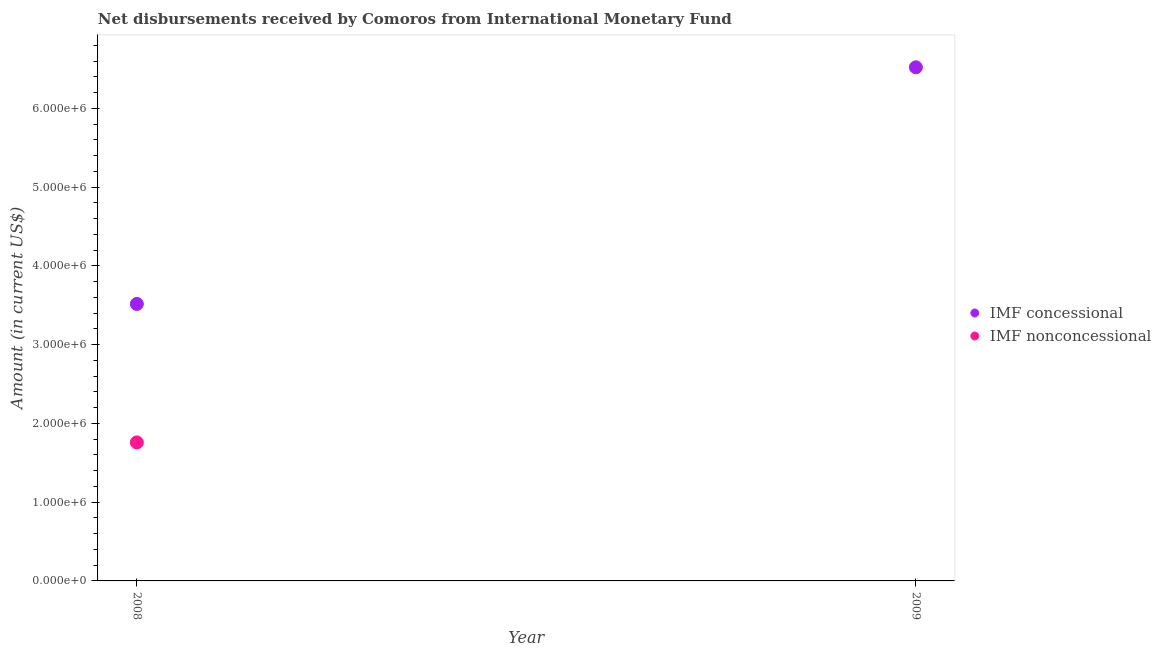Across all years, what is the maximum net non concessional disbursements from imf?
Give a very brief answer. 1.76e+06. In which year was the net concessional disbursements from imf maximum?
Your response must be concise. 2009. What is the total net concessional disbursements from imf in the graph?
Provide a short and direct response. 1.00e+07. What is the difference between the net concessional disbursements from imf in 2008 and that in 2009?
Make the answer very short. -3.00e+06. What is the difference between the net concessional disbursements from imf in 2009 and the net non concessional disbursements from imf in 2008?
Your answer should be compact. 4.76e+06. What is the average net non concessional disbursements from imf per year?
Provide a short and direct response. 8.80e+05. In the year 2008, what is the difference between the net concessional disbursements from imf and net non concessional disbursements from imf?
Offer a terse response. 1.76e+06. What is the ratio of the net concessional disbursements from imf in 2008 to that in 2009?
Provide a short and direct response. 0.54. Does the net non concessional disbursements from imf monotonically increase over the years?
Offer a terse response. No. Is the net concessional disbursements from imf strictly greater than the net non concessional disbursements from imf over the years?
Give a very brief answer. Yes. Is the net concessional disbursements from imf strictly less than the net non concessional disbursements from imf over the years?
Provide a short and direct response. No. How many years are there in the graph?
Your answer should be compact. 2. Are the values on the major ticks of Y-axis written in scientific E-notation?
Provide a succinct answer. Yes. Does the graph contain grids?
Your answer should be very brief. No. How many legend labels are there?
Offer a very short reply. 2. How are the legend labels stacked?
Keep it short and to the point. Vertical. What is the title of the graph?
Your response must be concise. Net disbursements received by Comoros from International Monetary Fund. Does "DAC donors" appear as one of the legend labels in the graph?
Offer a very short reply. No. What is the Amount (in current US$) of IMF concessional in 2008?
Make the answer very short. 3.52e+06. What is the Amount (in current US$) in IMF nonconcessional in 2008?
Keep it short and to the point. 1.76e+06. What is the Amount (in current US$) in IMF concessional in 2009?
Offer a very short reply. 6.52e+06. What is the Amount (in current US$) of IMF nonconcessional in 2009?
Give a very brief answer. 0. Across all years, what is the maximum Amount (in current US$) of IMF concessional?
Your answer should be very brief. 6.52e+06. Across all years, what is the maximum Amount (in current US$) of IMF nonconcessional?
Your answer should be very brief. 1.76e+06. Across all years, what is the minimum Amount (in current US$) in IMF concessional?
Offer a very short reply. 3.52e+06. What is the total Amount (in current US$) in IMF concessional in the graph?
Ensure brevity in your answer.  1.00e+07. What is the total Amount (in current US$) in IMF nonconcessional in the graph?
Ensure brevity in your answer.  1.76e+06. What is the difference between the Amount (in current US$) of IMF concessional in 2008 and that in 2009?
Provide a short and direct response. -3.00e+06. What is the average Amount (in current US$) of IMF concessional per year?
Your response must be concise. 5.02e+06. What is the average Amount (in current US$) of IMF nonconcessional per year?
Ensure brevity in your answer.  8.80e+05. In the year 2008, what is the difference between the Amount (in current US$) in IMF concessional and Amount (in current US$) in IMF nonconcessional?
Your answer should be compact. 1.76e+06. What is the ratio of the Amount (in current US$) in IMF concessional in 2008 to that in 2009?
Provide a short and direct response. 0.54. What is the difference between the highest and the second highest Amount (in current US$) of IMF concessional?
Give a very brief answer. 3.00e+06. What is the difference between the highest and the lowest Amount (in current US$) in IMF concessional?
Your response must be concise. 3.00e+06. What is the difference between the highest and the lowest Amount (in current US$) in IMF nonconcessional?
Ensure brevity in your answer.  1.76e+06. 